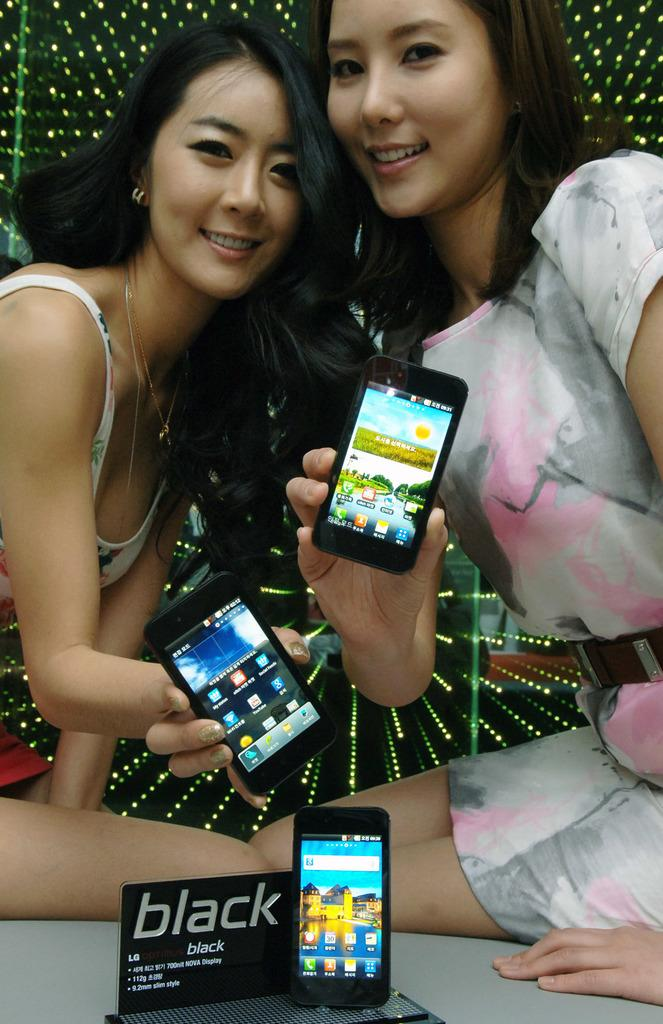<image>
Give a short and clear explanation of the subsequent image. Women holding some phones next to a sign that says BLACK. 